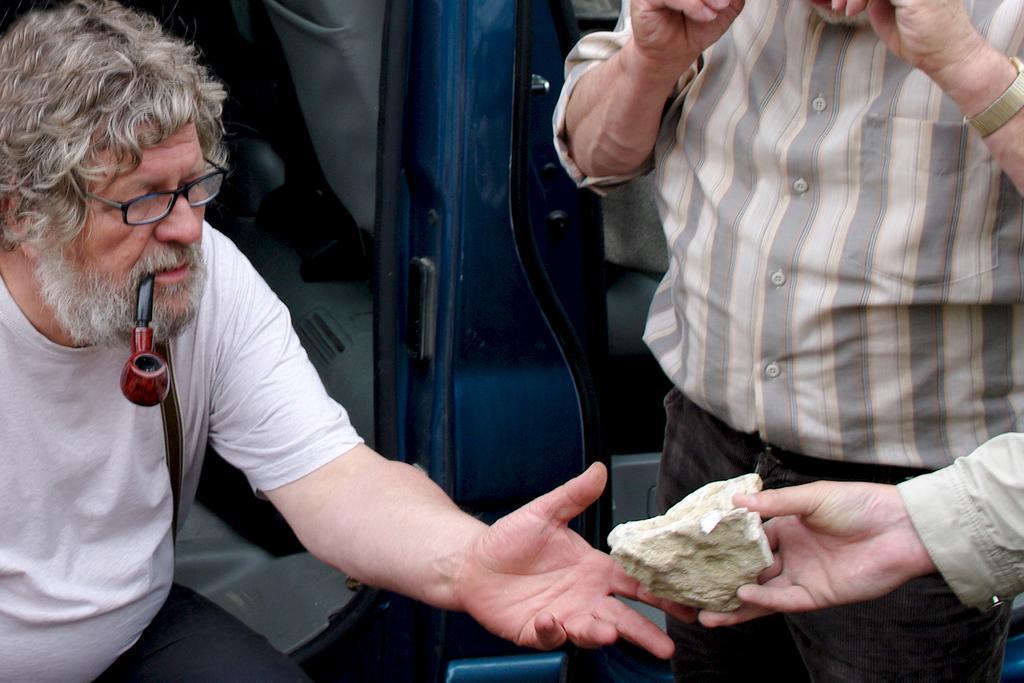Could you give a brief overview of what you see in this image? There is a person wearing specs and is having pipe in the mouth. And another person is standing. Also we can see a person's hand with a stone. 